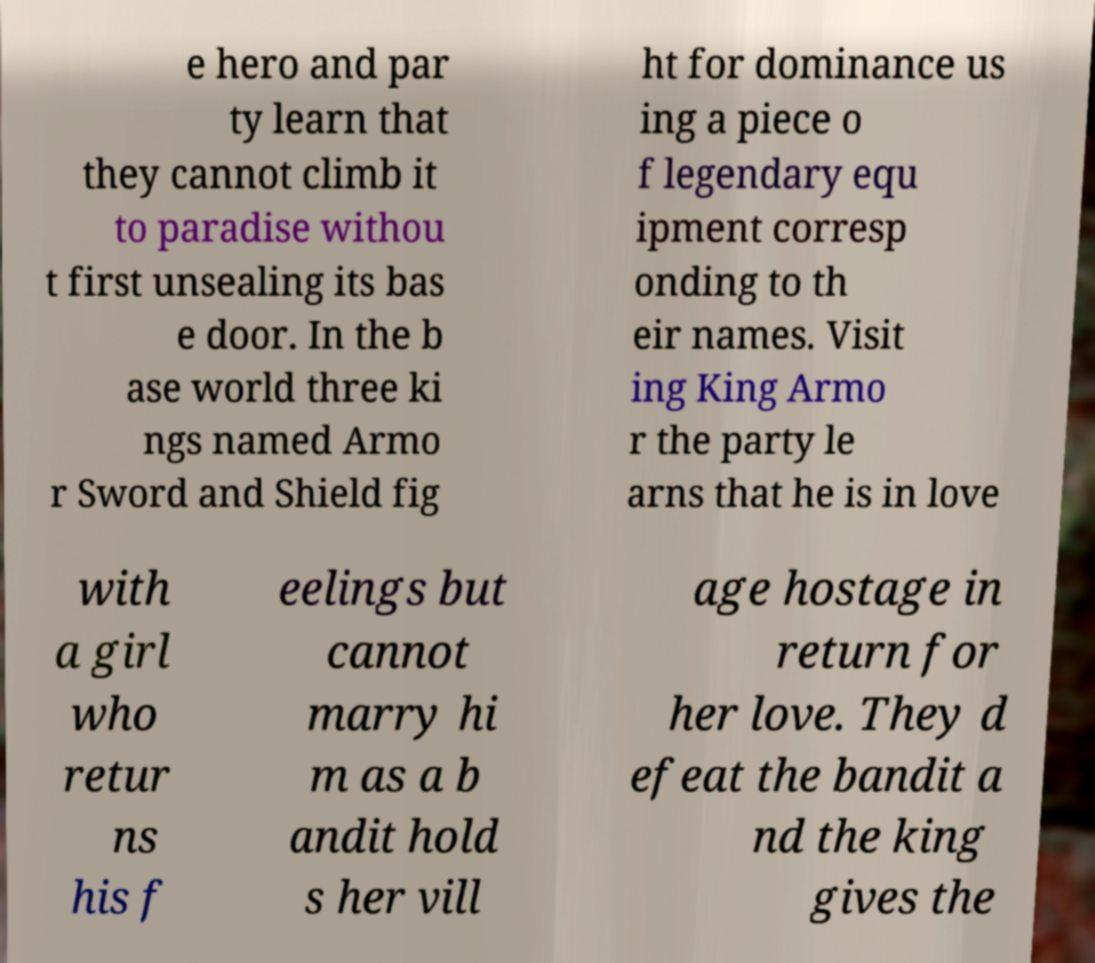Please read and relay the text visible in this image. What does it say? e hero and par ty learn that they cannot climb it to paradise withou t first unsealing its bas e door. In the b ase world three ki ngs named Armo r Sword and Shield fig ht for dominance us ing a piece o f legendary equ ipment corresp onding to th eir names. Visit ing King Armo r the party le arns that he is in love with a girl who retur ns his f eelings but cannot marry hi m as a b andit hold s her vill age hostage in return for her love. They d efeat the bandit a nd the king gives the 